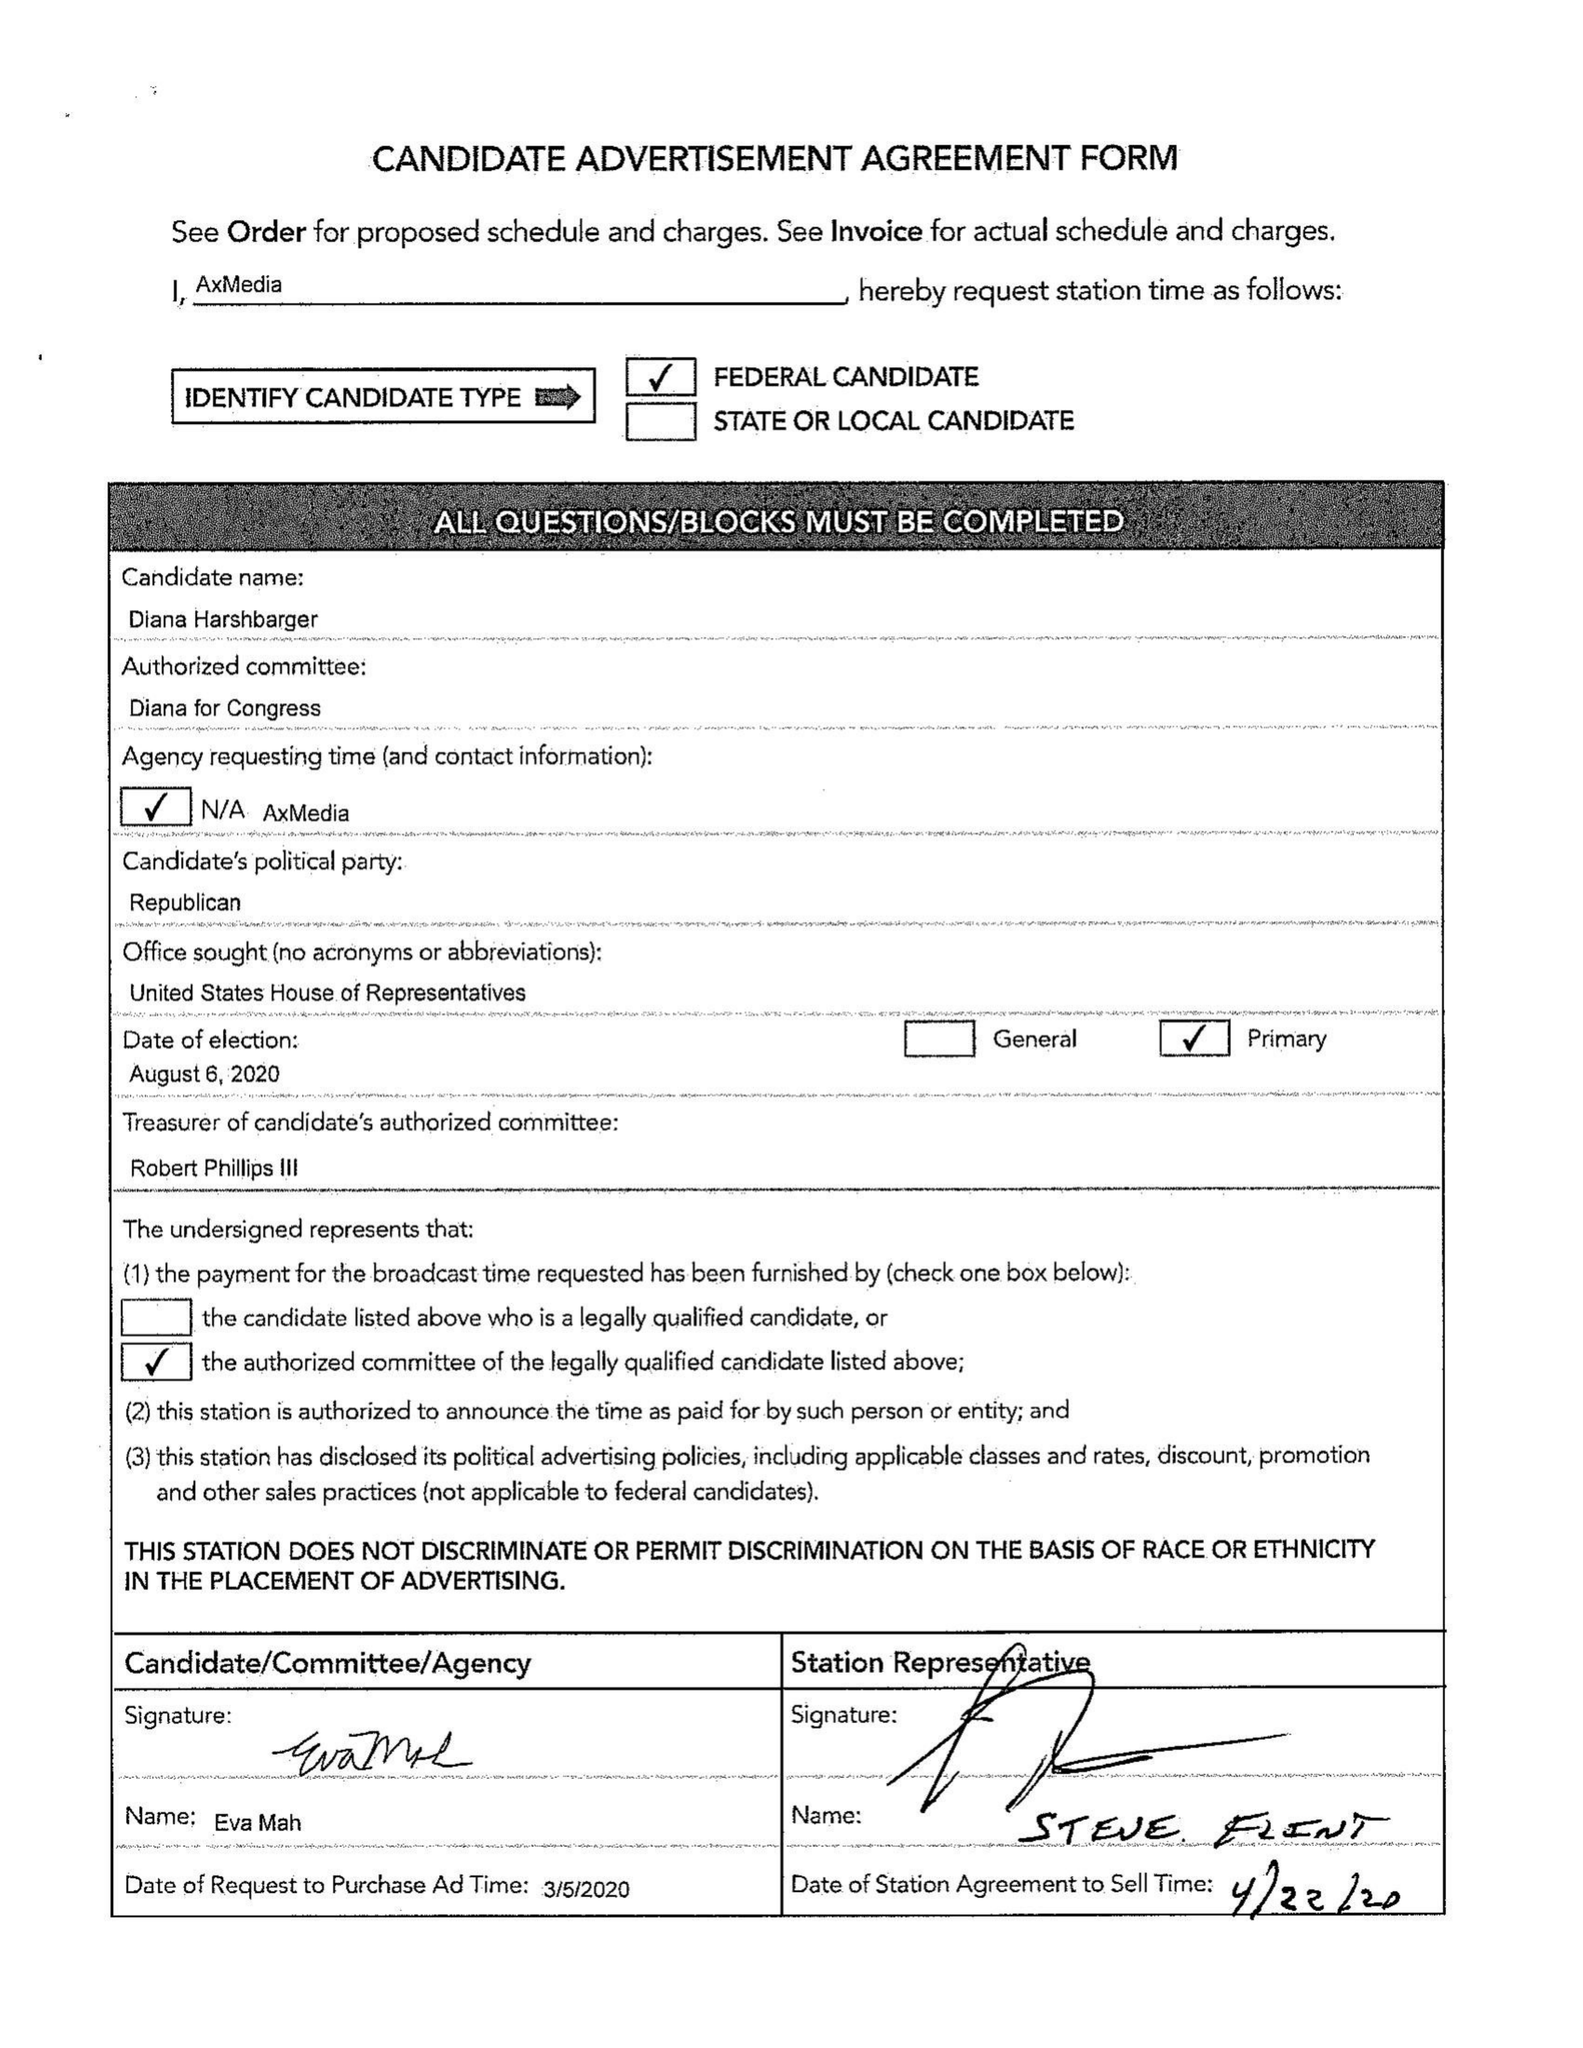What is the value for the flight_to?
Answer the question using a single word or phrase. 04/12/20 